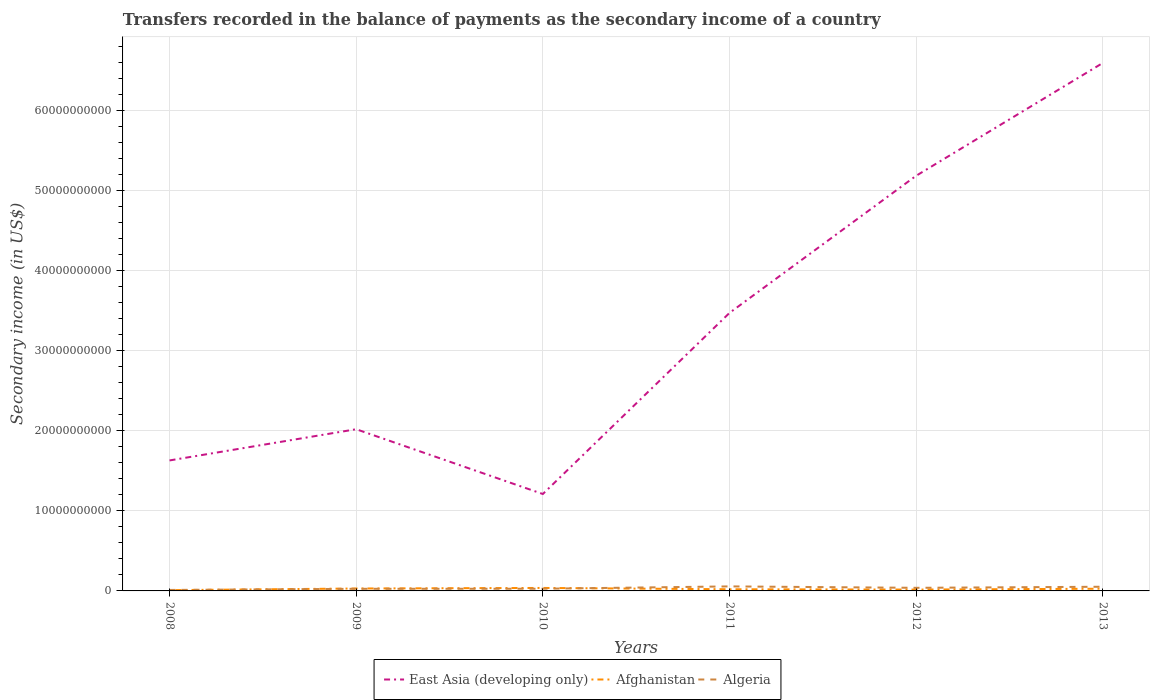How many different coloured lines are there?
Provide a succinct answer. 3. Does the line corresponding to East Asia (developing only) intersect with the line corresponding to Algeria?
Offer a terse response. No. Across all years, what is the maximum secondary income of in Afghanistan?
Your response must be concise. 9.67e+07. In which year was the secondary income of in Afghanistan maximum?
Your response must be concise. 2008. What is the total secondary income of in Algeria in the graph?
Your answer should be compact. -4.00e+08. What is the difference between the highest and the second highest secondary income of in East Asia (developing only)?
Offer a very short reply. 5.38e+1. What is the difference between the highest and the lowest secondary income of in Algeria?
Offer a terse response. 3. Is the secondary income of in Algeria strictly greater than the secondary income of in East Asia (developing only) over the years?
Make the answer very short. Yes. How many lines are there?
Your answer should be compact. 3. Does the graph contain grids?
Your answer should be very brief. Yes. Where does the legend appear in the graph?
Provide a short and direct response. Bottom center. How many legend labels are there?
Offer a terse response. 3. What is the title of the graph?
Give a very brief answer. Transfers recorded in the balance of payments as the secondary income of a country. What is the label or title of the X-axis?
Offer a very short reply. Years. What is the label or title of the Y-axis?
Provide a short and direct response. Secondary income (in US$). What is the Secondary income (in US$) in East Asia (developing only) in 2008?
Provide a succinct answer. 1.63e+1. What is the Secondary income (in US$) in Afghanistan in 2008?
Offer a terse response. 9.67e+07. What is the Secondary income (in US$) of Algeria in 2008?
Offer a terse response. 1.22e+08. What is the Secondary income (in US$) in East Asia (developing only) in 2009?
Your answer should be compact. 2.02e+1. What is the Secondary income (in US$) in Afghanistan in 2009?
Give a very brief answer. 3.02e+08. What is the Secondary income (in US$) of Algeria in 2009?
Offer a very short reply. 2.64e+08. What is the Secondary income (in US$) in East Asia (developing only) in 2010?
Your response must be concise. 1.21e+1. What is the Secondary income (in US$) of Afghanistan in 2010?
Your response must be concise. 3.73e+08. What is the Secondary income (in US$) of Algeria in 2010?
Make the answer very short. 2.73e+08. What is the Secondary income (in US$) of East Asia (developing only) in 2011?
Make the answer very short. 3.47e+1. What is the Secondary income (in US$) in Afghanistan in 2011?
Provide a succinct answer. 2.08e+08. What is the Secondary income (in US$) in Algeria in 2011?
Give a very brief answer. 5.65e+08. What is the Secondary income (in US$) of East Asia (developing only) in 2012?
Provide a succinct answer. 5.18e+1. What is the Secondary income (in US$) of Afghanistan in 2012?
Your answer should be compact. 1.68e+08. What is the Secondary income (in US$) in Algeria in 2012?
Your answer should be very brief. 3.87e+08. What is the Secondary income (in US$) in East Asia (developing only) in 2013?
Ensure brevity in your answer.  6.59e+1. What is the Secondary income (in US$) of Afghanistan in 2013?
Your answer should be very brief. 2.75e+08. What is the Secondary income (in US$) of Algeria in 2013?
Your answer should be compact. 5.22e+08. Across all years, what is the maximum Secondary income (in US$) of East Asia (developing only)?
Ensure brevity in your answer.  6.59e+1. Across all years, what is the maximum Secondary income (in US$) of Afghanistan?
Provide a succinct answer. 3.73e+08. Across all years, what is the maximum Secondary income (in US$) in Algeria?
Provide a short and direct response. 5.65e+08. Across all years, what is the minimum Secondary income (in US$) in East Asia (developing only)?
Your response must be concise. 1.21e+1. Across all years, what is the minimum Secondary income (in US$) in Afghanistan?
Your answer should be compact. 9.67e+07. Across all years, what is the minimum Secondary income (in US$) of Algeria?
Make the answer very short. 1.22e+08. What is the total Secondary income (in US$) in East Asia (developing only) in the graph?
Your answer should be compact. 2.01e+11. What is the total Secondary income (in US$) of Afghanistan in the graph?
Ensure brevity in your answer.  1.42e+09. What is the total Secondary income (in US$) in Algeria in the graph?
Offer a very short reply. 2.13e+09. What is the difference between the Secondary income (in US$) in East Asia (developing only) in 2008 and that in 2009?
Give a very brief answer. -3.90e+09. What is the difference between the Secondary income (in US$) in Afghanistan in 2008 and that in 2009?
Your answer should be very brief. -2.06e+08. What is the difference between the Secondary income (in US$) in Algeria in 2008 and that in 2009?
Your response must be concise. -1.42e+08. What is the difference between the Secondary income (in US$) in East Asia (developing only) in 2008 and that in 2010?
Make the answer very short. 4.19e+09. What is the difference between the Secondary income (in US$) in Afghanistan in 2008 and that in 2010?
Provide a short and direct response. -2.76e+08. What is the difference between the Secondary income (in US$) in Algeria in 2008 and that in 2010?
Your answer should be very brief. -1.51e+08. What is the difference between the Secondary income (in US$) in East Asia (developing only) in 2008 and that in 2011?
Your response must be concise. -1.84e+1. What is the difference between the Secondary income (in US$) in Afghanistan in 2008 and that in 2011?
Your response must be concise. -1.11e+08. What is the difference between the Secondary income (in US$) of Algeria in 2008 and that in 2011?
Provide a short and direct response. -4.43e+08. What is the difference between the Secondary income (in US$) in East Asia (developing only) in 2008 and that in 2012?
Provide a short and direct response. -3.56e+1. What is the difference between the Secondary income (in US$) in Afghanistan in 2008 and that in 2012?
Your answer should be very brief. -7.17e+07. What is the difference between the Secondary income (in US$) in Algeria in 2008 and that in 2012?
Keep it short and to the point. -2.65e+08. What is the difference between the Secondary income (in US$) in East Asia (developing only) in 2008 and that in 2013?
Give a very brief answer. -4.96e+1. What is the difference between the Secondary income (in US$) of Afghanistan in 2008 and that in 2013?
Provide a short and direct response. -1.79e+08. What is the difference between the Secondary income (in US$) in Algeria in 2008 and that in 2013?
Your answer should be compact. -4.00e+08. What is the difference between the Secondary income (in US$) in East Asia (developing only) in 2009 and that in 2010?
Offer a very short reply. 8.09e+09. What is the difference between the Secondary income (in US$) in Afghanistan in 2009 and that in 2010?
Offer a very short reply. -7.02e+07. What is the difference between the Secondary income (in US$) of Algeria in 2009 and that in 2010?
Ensure brevity in your answer.  -9.57e+06. What is the difference between the Secondary income (in US$) in East Asia (developing only) in 2009 and that in 2011?
Ensure brevity in your answer.  -1.45e+1. What is the difference between the Secondary income (in US$) of Afghanistan in 2009 and that in 2011?
Your response must be concise. 9.45e+07. What is the difference between the Secondary income (in US$) of Algeria in 2009 and that in 2011?
Provide a short and direct response. -3.02e+08. What is the difference between the Secondary income (in US$) of East Asia (developing only) in 2009 and that in 2012?
Ensure brevity in your answer.  -3.17e+1. What is the difference between the Secondary income (in US$) in Afghanistan in 2009 and that in 2012?
Make the answer very short. 1.34e+08. What is the difference between the Secondary income (in US$) of Algeria in 2009 and that in 2012?
Provide a succinct answer. -1.24e+08. What is the difference between the Secondary income (in US$) of East Asia (developing only) in 2009 and that in 2013?
Ensure brevity in your answer.  -4.57e+1. What is the difference between the Secondary income (in US$) of Afghanistan in 2009 and that in 2013?
Your answer should be compact. 2.69e+07. What is the difference between the Secondary income (in US$) of Algeria in 2009 and that in 2013?
Your answer should be compact. -2.59e+08. What is the difference between the Secondary income (in US$) in East Asia (developing only) in 2010 and that in 2011?
Give a very brief answer. -2.26e+1. What is the difference between the Secondary income (in US$) in Afghanistan in 2010 and that in 2011?
Offer a terse response. 1.65e+08. What is the difference between the Secondary income (in US$) of Algeria in 2010 and that in 2011?
Make the answer very short. -2.92e+08. What is the difference between the Secondary income (in US$) in East Asia (developing only) in 2010 and that in 2012?
Keep it short and to the point. -3.97e+1. What is the difference between the Secondary income (in US$) in Afghanistan in 2010 and that in 2012?
Give a very brief answer. 2.04e+08. What is the difference between the Secondary income (in US$) in Algeria in 2010 and that in 2012?
Provide a succinct answer. -1.14e+08. What is the difference between the Secondary income (in US$) in East Asia (developing only) in 2010 and that in 2013?
Offer a terse response. -5.38e+1. What is the difference between the Secondary income (in US$) of Afghanistan in 2010 and that in 2013?
Provide a succinct answer. 9.71e+07. What is the difference between the Secondary income (in US$) in Algeria in 2010 and that in 2013?
Keep it short and to the point. -2.49e+08. What is the difference between the Secondary income (in US$) in East Asia (developing only) in 2011 and that in 2012?
Keep it short and to the point. -1.71e+1. What is the difference between the Secondary income (in US$) in Afghanistan in 2011 and that in 2012?
Offer a very short reply. 3.94e+07. What is the difference between the Secondary income (in US$) of Algeria in 2011 and that in 2012?
Provide a succinct answer. 1.78e+08. What is the difference between the Secondary income (in US$) of East Asia (developing only) in 2011 and that in 2013?
Provide a succinct answer. -3.12e+1. What is the difference between the Secondary income (in US$) of Afghanistan in 2011 and that in 2013?
Make the answer very short. -6.76e+07. What is the difference between the Secondary income (in US$) in Algeria in 2011 and that in 2013?
Give a very brief answer. 4.29e+07. What is the difference between the Secondary income (in US$) of East Asia (developing only) in 2012 and that in 2013?
Provide a short and direct response. -1.41e+1. What is the difference between the Secondary income (in US$) of Afghanistan in 2012 and that in 2013?
Your response must be concise. -1.07e+08. What is the difference between the Secondary income (in US$) of Algeria in 2012 and that in 2013?
Provide a succinct answer. -1.35e+08. What is the difference between the Secondary income (in US$) in East Asia (developing only) in 2008 and the Secondary income (in US$) in Afghanistan in 2009?
Offer a terse response. 1.60e+1. What is the difference between the Secondary income (in US$) in East Asia (developing only) in 2008 and the Secondary income (in US$) in Algeria in 2009?
Your answer should be compact. 1.60e+1. What is the difference between the Secondary income (in US$) in Afghanistan in 2008 and the Secondary income (in US$) in Algeria in 2009?
Offer a terse response. -1.67e+08. What is the difference between the Secondary income (in US$) of East Asia (developing only) in 2008 and the Secondary income (in US$) of Afghanistan in 2010?
Your answer should be compact. 1.59e+1. What is the difference between the Secondary income (in US$) of East Asia (developing only) in 2008 and the Secondary income (in US$) of Algeria in 2010?
Your answer should be very brief. 1.60e+1. What is the difference between the Secondary income (in US$) of Afghanistan in 2008 and the Secondary income (in US$) of Algeria in 2010?
Keep it short and to the point. -1.76e+08. What is the difference between the Secondary income (in US$) of East Asia (developing only) in 2008 and the Secondary income (in US$) of Afghanistan in 2011?
Offer a terse response. 1.61e+1. What is the difference between the Secondary income (in US$) of East Asia (developing only) in 2008 and the Secondary income (in US$) of Algeria in 2011?
Offer a terse response. 1.57e+1. What is the difference between the Secondary income (in US$) of Afghanistan in 2008 and the Secondary income (in US$) of Algeria in 2011?
Make the answer very short. -4.69e+08. What is the difference between the Secondary income (in US$) of East Asia (developing only) in 2008 and the Secondary income (in US$) of Afghanistan in 2012?
Ensure brevity in your answer.  1.61e+1. What is the difference between the Secondary income (in US$) in East Asia (developing only) in 2008 and the Secondary income (in US$) in Algeria in 2012?
Your response must be concise. 1.59e+1. What is the difference between the Secondary income (in US$) in Afghanistan in 2008 and the Secondary income (in US$) in Algeria in 2012?
Keep it short and to the point. -2.90e+08. What is the difference between the Secondary income (in US$) of East Asia (developing only) in 2008 and the Secondary income (in US$) of Afghanistan in 2013?
Your response must be concise. 1.60e+1. What is the difference between the Secondary income (in US$) of East Asia (developing only) in 2008 and the Secondary income (in US$) of Algeria in 2013?
Make the answer very short. 1.58e+1. What is the difference between the Secondary income (in US$) of Afghanistan in 2008 and the Secondary income (in US$) of Algeria in 2013?
Provide a short and direct response. -4.26e+08. What is the difference between the Secondary income (in US$) of East Asia (developing only) in 2009 and the Secondary income (in US$) of Afghanistan in 2010?
Your answer should be very brief. 1.98e+1. What is the difference between the Secondary income (in US$) of East Asia (developing only) in 2009 and the Secondary income (in US$) of Algeria in 2010?
Offer a very short reply. 1.99e+1. What is the difference between the Secondary income (in US$) of Afghanistan in 2009 and the Secondary income (in US$) of Algeria in 2010?
Offer a terse response. 2.92e+07. What is the difference between the Secondary income (in US$) in East Asia (developing only) in 2009 and the Secondary income (in US$) in Afghanistan in 2011?
Your response must be concise. 2.00e+1. What is the difference between the Secondary income (in US$) in East Asia (developing only) in 2009 and the Secondary income (in US$) in Algeria in 2011?
Ensure brevity in your answer.  1.96e+1. What is the difference between the Secondary income (in US$) in Afghanistan in 2009 and the Secondary income (in US$) in Algeria in 2011?
Your answer should be compact. -2.63e+08. What is the difference between the Secondary income (in US$) in East Asia (developing only) in 2009 and the Secondary income (in US$) in Afghanistan in 2012?
Keep it short and to the point. 2.00e+1. What is the difference between the Secondary income (in US$) of East Asia (developing only) in 2009 and the Secondary income (in US$) of Algeria in 2012?
Ensure brevity in your answer.  1.98e+1. What is the difference between the Secondary income (in US$) in Afghanistan in 2009 and the Secondary income (in US$) in Algeria in 2012?
Offer a terse response. -8.49e+07. What is the difference between the Secondary income (in US$) in East Asia (developing only) in 2009 and the Secondary income (in US$) in Afghanistan in 2013?
Offer a terse response. 1.99e+1. What is the difference between the Secondary income (in US$) in East Asia (developing only) in 2009 and the Secondary income (in US$) in Algeria in 2013?
Provide a succinct answer. 1.97e+1. What is the difference between the Secondary income (in US$) in Afghanistan in 2009 and the Secondary income (in US$) in Algeria in 2013?
Your response must be concise. -2.20e+08. What is the difference between the Secondary income (in US$) of East Asia (developing only) in 2010 and the Secondary income (in US$) of Afghanistan in 2011?
Provide a succinct answer. 1.19e+1. What is the difference between the Secondary income (in US$) in East Asia (developing only) in 2010 and the Secondary income (in US$) in Algeria in 2011?
Provide a succinct answer. 1.15e+1. What is the difference between the Secondary income (in US$) of Afghanistan in 2010 and the Secondary income (in US$) of Algeria in 2011?
Your answer should be compact. -1.93e+08. What is the difference between the Secondary income (in US$) in East Asia (developing only) in 2010 and the Secondary income (in US$) in Afghanistan in 2012?
Your answer should be very brief. 1.19e+1. What is the difference between the Secondary income (in US$) in East Asia (developing only) in 2010 and the Secondary income (in US$) in Algeria in 2012?
Make the answer very short. 1.17e+1. What is the difference between the Secondary income (in US$) in Afghanistan in 2010 and the Secondary income (in US$) in Algeria in 2012?
Keep it short and to the point. -1.47e+07. What is the difference between the Secondary income (in US$) of East Asia (developing only) in 2010 and the Secondary income (in US$) of Afghanistan in 2013?
Your answer should be compact. 1.18e+1. What is the difference between the Secondary income (in US$) of East Asia (developing only) in 2010 and the Secondary income (in US$) of Algeria in 2013?
Your answer should be very brief. 1.16e+1. What is the difference between the Secondary income (in US$) of Afghanistan in 2010 and the Secondary income (in US$) of Algeria in 2013?
Offer a terse response. -1.50e+08. What is the difference between the Secondary income (in US$) in East Asia (developing only) in 2011 and the Secondary income (in US$) in Afghanistan in 2012?
Provide a short and direct response. 3.46e+1. What is the difference between the Secondary income (in US$) in East Asia (developing only) in 2011 and the Secondary income (in US$) in Algeria in 2012?
Keep it short and to the point. 3.43e+1. What is the difference between the Secondary income (in US$) of Afghanistan in 2011 and the Secondary income (in US$) of Algeria in 2012?
Make the answer very short. -1.79e+08. What is the difference between the Secondary income (in US$) of East Asia (developing only) in 2011 and the Secondary income (in US$) of Afghanistan in 2013?
Give a very brief answer. 3.44e+1. What is the difference between the Secondary income (in US$) in East Asia (developing only) in 2011 and the Secondary income (in US$) in Algeria in 2013?
Your answer should be compact. 3.42e+1. What is the difference between the Secondary income (in US$) of Afghanistan in 2011 and the Secondary income (in US$) of Algeria in 2013?
Provide a succinct answer. -3.15e+08. What is the difference between the Secondary income (in US$) in East Asia (developing only) in 2012 and the Secondary income (in US$) in Afghanistan in 2013?
Give a very brief answer. 5.16e+1. What is the difference between the Secondary income (in US$) in East Asia (developing only) in 2012 and the Secondary income (in US$) in Algeria in 2013?
Make the answer very short. 5.13e+1. What is the difference between the Secondary income (in US$) of Afghanistan in 2012 and the Secondary income (in US$) of Algeria in 2013?
Ensure brevity in your answer.  -3.54e+08. What is the average Secondary income (in US$) in East Asia (developing only) per year?
Provide a short and direct response. 3.35e+1. What is the average Secondary income (in US$) in Afghanistan per year?
Offer a very short reply. 2.37e+08. What is the average Secondary income (in US$) of Algeria per year?
Provide a succinct answer. 3.56e+08. In the year 2008, what is the difference between the Secondary income (in US$) in East Asia (developing only) and Secondary income (in US$) in Afghanistan?
Give a very brief answer. 1.62e+1. In the year 2008, what is the difference between the Secondary income (in US$) of East Asia (developing only) and Secondary income (in US$) of Algeria?
Offer a terse response. 1.62e+1. In the year 2008, what is the difference between the Secondary income (in US$) of Afghanistan and Secondary income (in US$) of Algeria?
Give a very brief answer. -2.51e+07. In the year 2009, what is the difference between the Secondary income (in US$) in East Asia (developing only) and Secondary income (in US$) in Afghanistan?
Offer a very short reply. 1.99e+1. In the year 2009, what is the difference between the Secondary income (in US$) in East Asia (developing only) and Secondary income (in US$) in Algeria?
Provide a short and direct response. 1.99e+1. In the year 2009, what is the difference between the Secondary income (in US$) of Afghanistan and Secondary income (in US$) of Algeria?
Offer a very short reply. 3.87e+07. In the year 2010, what is the difference between the Secondary income (in US$) in East Asia (developing only) and Secondary income (in US$) in Afghanistan?
Make the answer very short. 1.17e+1. In the year 2010, what is the difference between the Secondary income (in US$) in East Asia (developing only) and Secondary income (in US$) in Algeria?
Provide a succinct answer. 1.18e+1. In the year 2010, what is the difference between the Secondary income (in US$) of Afghanistan and Secondary income (in US$) of Algeria?
Make the answer very short. 9.93e+07. In the year 2011, what is the difference between the Secondary income (in US$) of East Asia (developing only) and Secondary income (in US$) of Afghanistan?
Give a very brief answer. 3.45e+1. In the year 2011, what is the difference between the Secondary income (in US$) of East Asia (developing only) and Secondary income (in US$) of Algeria?
Your answer should be very brief. 3.42e+1. In the year 2011, what is the difference between the Secondary income (in US$) in Afghanistan and Secondary income (in US$) in Algeria?
Keep it short and to the point. -3.57e+08. In the year 2012, what is the difference between the Secondary income (in US$) of East Asia (developing only) and Secondary income (in US$) of Afghanistan?
Your response must be concise. 5.17e+1. In the year 2012, what is the difference between the Secondary income (in US$) of East Asia (developing only) and Secondary income (in US$) of Algeria?
Your response must be concise. 5.15e+1. In the year 2012, what is the difference between the Secondary income (in US$) of Afghanistan and Secondary income (in US$) of Algeria?
Give a very brief answer. -2.19e+08. In the year 2013, what is the difference between the Secondary income (in US$) in East Asia (developing only) and Secondary income (in US$) in Afghanistan?
Your answer should be compact. 6.57e+1. In the year 2013, what is the difference between the Secondary income (in US$) of East Asia (developing only) and Secondary income (in US$) of Algeria?
Ensure brevity in your answer.  6.54e+1. In the year 2013, what is the difference between the Secondary income (in US$) in Afghanistan and Secondary income (in US$) in Algeria?
Give a very brief answer. -2.47e+08. What is the ratio of the Secondary income (in US$) in East Asia (developing only) in 2008 to that in 2009?
Provide a succinct answer. 0.81. What is the ratio of the Secondary income (in US$) in Afghanistan in 2008 to that in 2009?
Your answer should be very brief. 0.32. What is the ratio of the Secondary income (in US$) in Algeria in 2008 to that in 2009?
Offer a very short reply. 0.46. What is the ratio of the Secondary income (in US$) in East Asia (developing only) in 2008 to that in 2010?
Offer a terse response. 1.35. What is the ratio of the Secondary income (in US$) in Afghanistan in 2008 to that in 2010?
Provide a short and direct response. 0.26. What is the ratio of the Secondary income (in US$) of Algeria in 2008 to that in 2010?
Make the answer very short. 0.45. What is the ratio of the Secondary income (in US$) in East Asia (developing only) in 2008 to that in 2011?
Your answer should be compact. 0.47. What is the ratio of the Secondary income (in US$) in Afghanistan in 2008 to that in 2011?
Give a very brief answer. 0.47. What is the ratio of the Secondary income (in US$) in Algeria in 2008 to that in 2011?
Provide a succinct answer. 0.22. What is the ratio of the Secondary income (in US$) in East Asia (developing only) in 2008 to that in 2012?
Ensure brevity in your answer.  0.31. What is the ratio of the Secondary income (in US$) in Afghanistan in 2008 to that in 2012?
Offer a terse response. 0.57. What is the ratio of the Secondary income (in US$) of Algeria in 2008 to that in 2012?
Offer a terse response. 0.31. What is the ratio of the Secondary income (in US$) of East Asia (developing only) in 2008 to that in 2013?
Keep it short and to the point. 0.25. What is the ratio of the Secondary income (in US$) in Afghanistan in 2008 to that in 2013?
Offer a very short reply. 0.35. What is the ratio of the Secondary income (in US$) in Algeria in 2008 to that in 2013?
Provide a succinct answer. 0.23. What is the ratio of the Secondary income (in US$) of East Asia (developing only) in 2009 to that in 2010?
Make the answer very short. 1.67. What is the ratio of the Secondary income (in US$) in Afghanistan in 2009 to that in 2010?
Ensure brevity in your answer.  0.81. What is the ratio of the Secondary income (in US$) in Algeria in 2009 to that in 2010?
Offer a terse response. 0.96. What is the ratio of the Secondary income (in US$) of East Asia (developing only) in 2009 to that in 2011?
Give a very brief answer. 0.58. What is the ratio of the Secondary income (in US$) of Afghanistan in 2009 to that in 2011?
Your response must be concise. 1.45. What is the ratio of the Secondary income (in US$) in Algeria in 2009 to that in 2011?
Provide a succinct answer. 0.47. What is the ratio of the Secondary income (in US$) of East Asia (developing only) in 2009 to that in 2012?
Offer a very short reply. 0.39. What is the ratio of the Secondary income (in US$) in Afghanistan in 2009 to that in 2012?
Your answer should be compact. 1.8. What is the ratio of the Secondary income (in US$) in Algeria in 2009 to that in 2012?
Provide a succinct answer. 0.68. What is the ratio of the Secondary income (in US$) of East Asia (developing only) in 2009 to that in 2013?
Give a very brief answer. 0.31. What is the ratio of the Secondary income (in US$) of Afghanistan in 2009 to that in 2013?
Keep it short and to the point. 1.1. What is the ratio of the Secondary income (in US$) in Algeria in 2009 to that in 2013?
Keep it short and to the point. 0.5. What is the ratio of the Secondary income (in US$) in East Asia (developing only) in 2010 to that in 2011?
Ensure brevity in your answer.  0.35. What is the ratio of the Secondary income (in US$) in Afghanistan in 2010 to that in 2011?
Give a very brief answer. 1.79. What is the ratio of the Secondary income (in US$) in Algeria in 2010 to that in 2011?
Keep it short and to the point. 0.48. What is the ratio of the Secondary income (in US$) in East Asia (developing only) in 2010 to that in 2012?
Give a very brief answer. 0.23. What is the ratio of the Secondary income (in US$) of Afghanistan in 2010 to that in 2012?
Offer a terse response. 2.21. What is the ratio of the Secondary income (in US$) in Algeria in 2010 to that in 2012?
Your response must be concise. 0.71. What is the ratio of the Secondary income (in US$) of East Asia (developing only) in 2010 to that in 2013?
Offer a very short reply. 0.18. What is the ratio of the Secondary income (in US$) of Afghanistan in 2010 to that in 2013?
Give a very brief answer. 1.35. What is the ratio of the Secondary income (in US$) in Algeria in 2010 to that in 2013?
Ensure brevity in your answer.  0.52. What is the ratio of the Secondary income (in US$) in East Asia (developing only) in 2011 to that in 2012?
Keep it short and to the point. 0.67. What is the ratio of the Secondary income (in US$) of Afghanistan in 2011 to that in 2012?
Your answer should be compact. 1.23. What is the ratio of the Secondary income (in US$) in Algeria in 2011 to that in 2012?
Offer a terse response. 1.46. What is the ratio of the Secondary income (in US$) in East Asia (developing only) in 2011 to that in 2013?
Provide a succinct answer. 0.53. What is the ratio of the Secondary income (in US$) in Afghanistan in 2011 to that in 2013?
Offer a very short reply. 0.75. What is the ratio of the Secondary income (in US$) in Algeria in 2011 to that in 2013?
Your response must be concise. 1.08. What is the ratio of the Secondary income (in US$) in East Asia (developing only) in 2012 to that in 2013?
Your response must be concise. 0.79. What is the ratio of the Secondary income (in US$) in Afghanistan in 2012 to that in 2013?
Offer a very short reply. 0.61. What is the ratio of the Secondary income (in US$) in Algeria in 2012 to that in 2013?
Make the answer very short. 0.74. What is the difference between the highest and the second highest Secondary income (in US$) of East Asia (developing only)?
Offer a terse response. 1.41e+1. What is the difference between the highest and the second highest Secondary income (in US$) in Afghanistan?
Provide a short and direct response. 7.02e+07. What is the difference between the highest and the second highest Secondary income (in US$) in Algeria?
Give a very brief answer. 4.29e+07. What is the difference between the highest and the lowest Secondary income (in US$) in East Asia (developing only)?
Offer a very short reply. 5.38e+1. What is the difference between the highest and the lowest Secondary income (in US$) of Afghanistan?
Your answer should be compact. 2.76e+08. What is the difference between the highest and the lowest Secondary income (in US$) in Algeria?
Ensure brevity in your answer.  4.43e+08. 